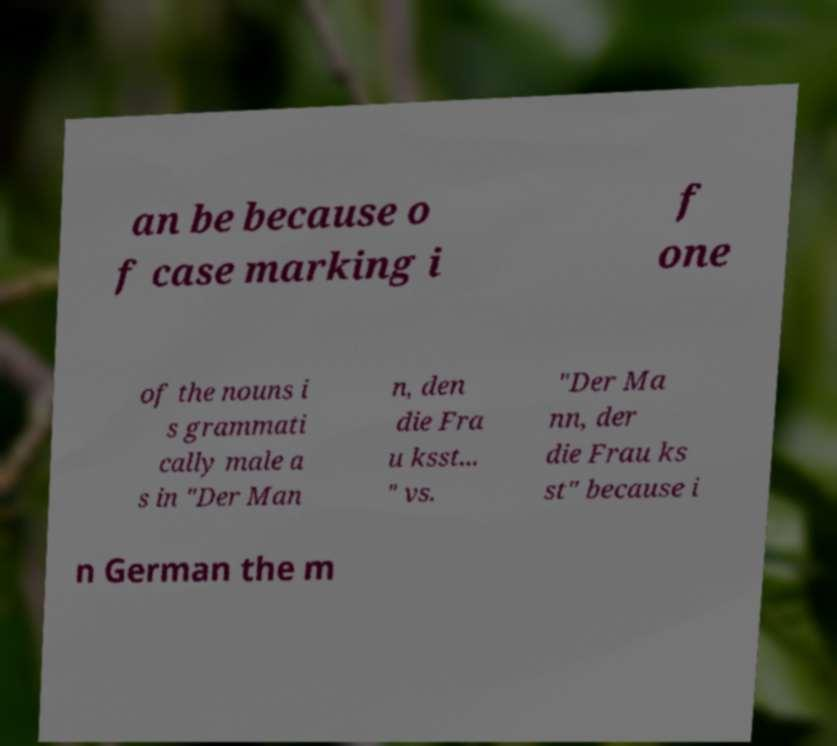Please read and relay the text visible in this image. What does it say? an be because o f case marking i f one of the nouns i s grammati cally male a s in "Der Man n, den die Fra u ksst... " vs. "Der Ma nn, der die Frau ks st" because i n German the m 